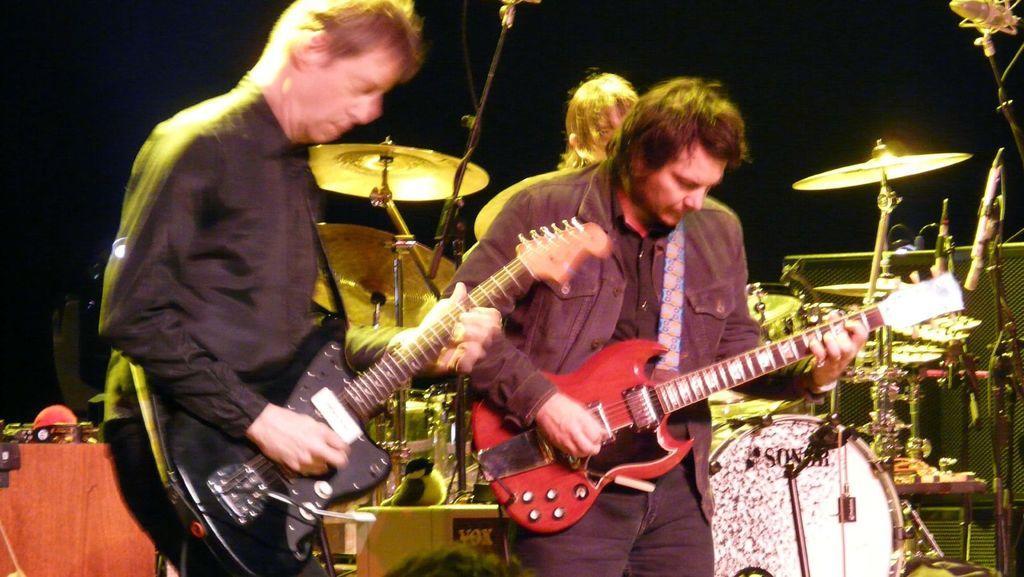Can you describe this image briefly? In this image I can see few people are playing the musical instruments. These people are wearing the different color dresses. I can also see many musical instruments and railing to the side. And there is a black background. 